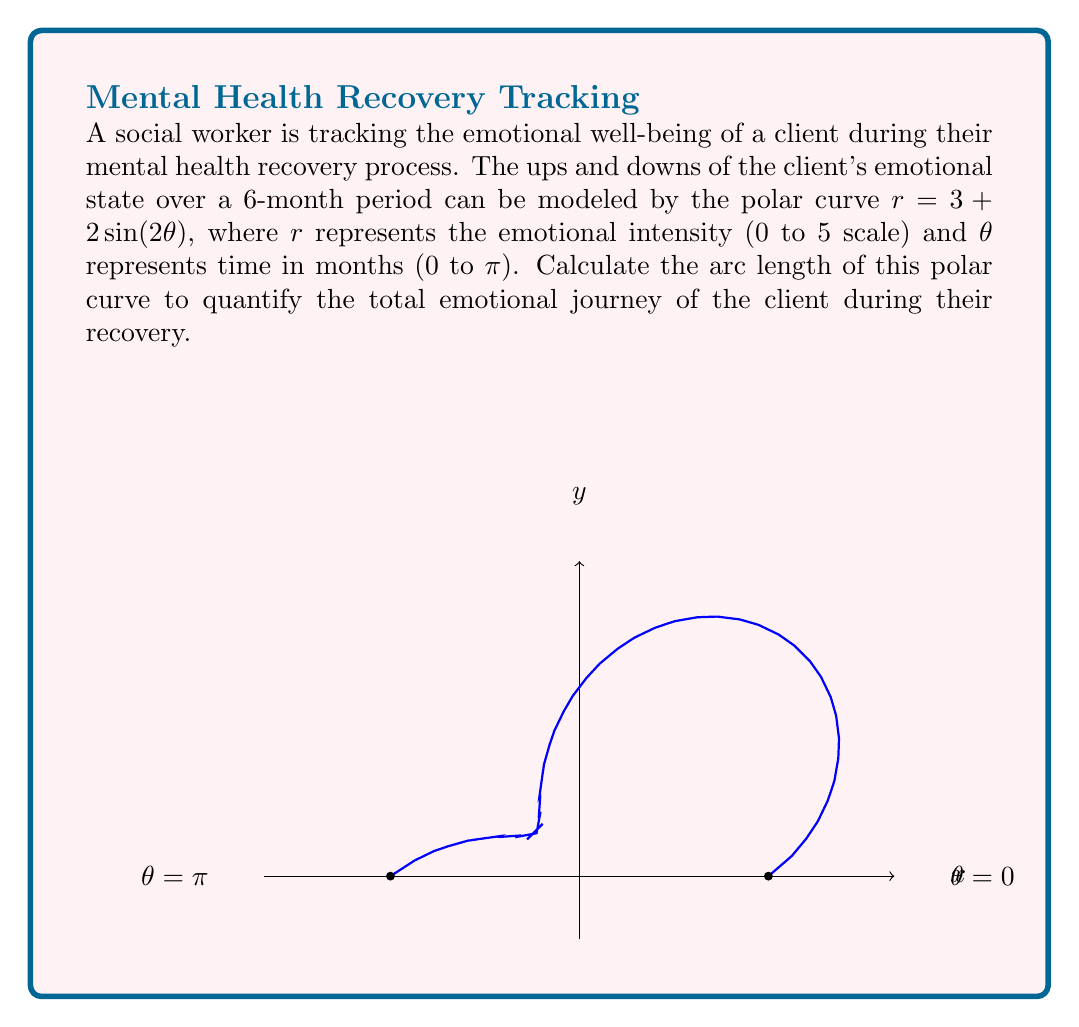Can you answer this question? To calculate the arc length of a polar curve, we use the formula:

$$ L = \int_a^b \sqrt{r^2 + \left(\frac{dr}{d\theta}\right)^2} d\theta $$

Where $r = 3 + 2\sin(2\theta)$ and $\theta$ ranges from 0 to $\pi$.

Step 1: Calculate $\frac{dr}{d\theta}$
$$ \frac{dr}{d\theta} = 4\cos(2\theta) $$

Step 2: Substitute into the arc length formula
$$ L = \int_0^\pi \sqrt{(3 + 2\sin(2\theta))^2 + (4\cos(2\theta))^2} d\theta $$

Step 3: Simplify the expression under the square root
$$ L = \int_0^\pi \sqrt{9 + 12\sin(2\theta) + 4\sin^2(2\theta) + 16\cos^2(2\theta)} d\theta $$
$$ L = \int_0^\pi \sqrt{9 + 12\sin(2\theta) + 4(\sin^2(2\theta) + 4\cos^2(2\theta))} d\theta $$
$$ L = \int_0^\pi \sqrt{13 + 12\sin(2\theta)} d\theta $$

Step 4: This integral cannot be evaluated analytically, so we need to use numerical integration methods. Using a computational tool or calculator with numerical integration capabilities, we can evaluate this integral.

Step 5: The result of the numerical integration is approximately 11.2395 units.

This value represents the total emotional journey of the client over the 6-month period, taking into account both the intensity and frequency of emotional changes.
Answer: $11.2395$ units 